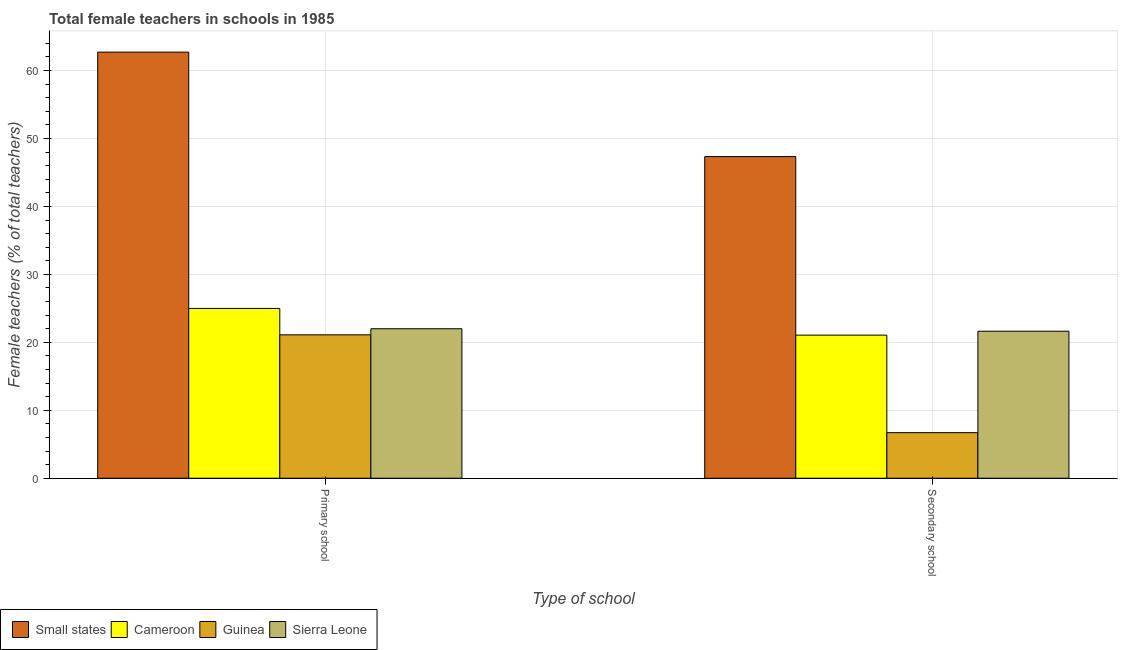How many different coloured bars are there?
Make the answer very short. 4. How many groups of bars are there?
Keep it short and to the point. 2. Are the number of bars per tick equal to the number of legend labels?
Your response must be concise. Yes. Are the number of bars on each tick of the X-axis equal?
Keep it short and to the point. Yes. What is the label of the 2nd group of bars from the left?
Offer a very short reply. Secondary school. What is the percentage of female teachers in secondary schools in Small states?
Offer a very short reply. 47.33. Across all countries, what is the maximum percentage of female teachers in primary schools?
Your response must be concise. 62.7. Across all countries, what is the minimum percentage of female teachers in secondary schools?
Your answer should be very brief. 6.71. In which country was the percentage of female teachers in secondary schools maximum?
Your response must be concise. Small states. In which country was the percentage of female teachers in secondary schools minimum?
Offer a very short reply. Guinea. What is the total percentage of female teachers in secondary schools in the graph?
Keep it short and to the point. 96.74. What is the difference between the percentage of female teachers in secondary schools in Cameroon and that in Guinea?
Keep it short and to the point. 14.35. What is the difference between the percentage of female teachers in primary schools in Cameroon and the percentage of female teachers in secondary schools in Guinea?
Your answer should be very brief. 18.28. What is the average percentage of female teachers in primary schools per country?
Offer a terse response. 32.7. What is the difference between the percentage of female teachers in secondary schools and percentage of female teachers in primary schools in Small states?
Give a very brief answer. -15.37. In how many countries, is the percentage of female teachers in secondary schools greater than 58 %?
Keep it short and to the point. 0. What is the ratio of the percentage of female teachers in secondary schools in Guinea to that in Small states?
Your answer should be compact. 0.14. Is the percentage of female teachers in primary schools in Small states less than that in Guinea?
Offer a very short reply. No. In how many countries, is the percentage of female teachers in secondary schools greater than the average percentage of female teachers in secondary schools taken over all countries?
Your answer should be very brief. 1. What does the 4th bar from the left in Secondary school represents?
Your response must be concise. Sierra Leone. What does the 3rd bar from the right in Secondary school represents?
Your answer should be very brief. Cameroon. Are all the bars in the graph horizontal?
Keep it short and to the point. No. Does the graph contain any zero values?
Your answer should be very brief. No. Does the graph contain grids?
Your response must be concise. Yes. How many legend labels are there?
Offer a very short reply. 4. What is the title of the graph?
Keep it short and to the point. Total female teachers in schools in 1985. Does "New Caledonia" appear as one of the legend labels in the graph?
Provide a short and direct response. No. What is the label or title of the X-axis?
Your response must be concise. Type of school. What is the label or title of the Y-axis?
Offer a terse response. Female teachers (% of total teachers). What is the Female teachers (% of total teachers) of Small states in Primary school?
Give a very brief answer. 62.7. What is the Female teachers (% of total teachers) of Cameroon in Primary school?
Your answer should be very brief. 24.99. What is the Female teachers (% of total teachers) in Guinea in Primary school?
Your answer should be very brief. 21.1. What is the Female teachers (% of total teachers) of Sierra Leone in Primary school?
Offer a terse response. 22. What is the Female teachers (% of total teachers) of Small states in Secondary school?
Your answer should be very brief. 47.33. What is the Female teachers (% of total teachers) of Cameroon in Secondary school?
Give a very brief answer. 21.06. What is the Female teachers (% of total teachers) of Guinea in Secondary school?
Provide a short and direct response. 6.71. What is the Female teachers (% of total teachers) of Sierra Leone in Secondary school?
Give a very brief answer. 21.64. Across all Type of school, what is the maximum Female teachers (% of total teachers) of Small states?
Offer a terse response. 62.7. Across all Type of school, what is the maximum Female teachers (% of total teachers) in Cameroon?
Provide a short and direct response. 24.99. Across all Type of school, what is the maximum Female teachers (% of total teachers) in Guinea?
Offer a very short reply. 21.1. Across all Type of school, what is the maximum Female teachers (% of total teachers) of Sierra Leone?
Provide a short and direct response. 22. Across all Type of school, what is the minimum Female teachers (% of total teachers) of Small states?
Ensure brevity in your answer.  47.33. Across all Type of school, what is the minimum Female teachers (% of total teachers) in Cameroon?
Your answer should be compact. 21.06. Across all Type of school, what is the minimum Female teachers (% of total teachers) in Guinea?
Make the answer very short. 6.71. Across all Type of school, what is the minimum Female teachers (% of total teachers) of Sierra Leone?
Give a very brief answer. 21.64. What is the total Female teachers (% of total teachers) in Small states in the graph?
Provide a short and direct response. 110.04. What is the total Female teachers (% of total teachers) of Cameroon in the graph?
Your answer should be compact. 46.04. What is the total Female teachers (% of total teachers) in Guinea in the graph?
Provide a short and direct response. 27.81. What is the total Female teachers (% of total teachers) in Sierra Leone in the graph?
Ensure brevity in your answer.  43.63. What is the difference between the Female teachers (% of total teachers) of Small states in Primary school and that in Secondary school?
Your response must be concise. 15.37. What is the difference between the Female teachers (% of total teachers) of Cameroon in Primary school and that in Secondary school?
Offer a very short reply. 3.93. What is the difference between the Female teachers (% of total teachers) in Guinea in Primary school and that in Secondary school?
Provide a short and direct response. 14.39. What is the difference between the Female teachers (% of total teachers) in Sierra Leone in Primary school and that in Secondary school?
Ensure brevity in your answer.  0.36. What is the difference between the Female teachers (% of total teachers) in Small states in Primary school and the Female teachers (% of total teachers) in Cameroon in Secondary school?
Offer a terse response. 41.65. What is the difference between the Female teachers (% of total teachers) in Small states in Primary school and the Female teachers (% of total teachers) in Guinea in Secondary school?
Offer a terse response. 56. What is the difference between the Female teachers (% of total teachers) of Small states in Primary school and the Female teachers (% of total teachers) of Sierra Leone in Secondary school?
Give a very brief answer. 41.07. What is the difference between the Female teachers (% of total teachers) in Cameroon in Primary school and the Female teachers (% of total teachers) in Guinea in Secondary school?
Ensure brevity in your answer.  18.28. What is the difference between the Female teachers (% of total teachers) of Cameroon in Primary school and the Female teachers (% of total teachers) of Sierra Leone in Secondary school?
Provide a succinct answer. 3.35. What is the difference between the Female teachers (% of total teachers) of Guinea in Primary school and the Female teachers (% of total teachers) of Sierra Leone in Secondary school?
Offer a terse response. -0.53. What is the average Female teachers (% of total teachers) of Small states per Type of school?
Your answer should be compact. 55.02. What is the average Female teachers (% of total teachers) in Cameroon per Type of school?
Make the answer very short. 23.02. What is the average Female teachers (% of total teachers) of Guinea per Type of school?
Offer a terse response. 13.91. What is the average Female teachers (% of total teachers) in Sierra Leone per Type of school?
Make the answer very short. 21.82. What is the difference between the Female teachers (% of total teachers) of Small states and Female teachers (% of total teachers) of Cameroon in Primary school?
Provide a succinct answer. 37.72. What is the difference between the Female teachers (% of total teachers) in Small states and Female teachers (% of total teachers) in Guinea in Primary school?
Ensure brevity in your answer.  41.6. What is the difference between the Female teachers (% of total teachers) in Small states and Female teachers (% of total teachers) in Sierra Leone in Primary school?
Make the answer very short. 40.71. What is the difference between the Female teachers (% of total teachers) in Cameroon and Female teachers (% of total teachers) in Guinea in Primary school?
Offer a very short reply. 3.88. What is the difference between the Female teachers (% of total teachers) of Cameroon and Female teachers (% of total teachers) of Sierra Leone in Primary school?
Ensure brevity in your answer.  2.99. What is the difference between the Female teachers (% of total teachers) in Guinea and Female teachers (% of total teachers) in Sierra Leone in Primary school?
Provide a short and direct response. -0.9. What is the difference between the Female teachers (% of total teachers) in Small states and Female teachers (% of total teachers) in Cameroon in Secondary school?
Your answer should be compact. 26.27. What is the difference between the Female teachers (% of total teachers) in Small states and Female teachers (% of total teachers) in Guinea in Secondary school?
Offer a terse response. 40.63. What is the difference between the Female teachers (% of total teachers) of Small states and Female teachers (% of total teachers) of Sierra Leone in Secondary school?
Your answer should be very brief. 25.7. What is the difference between the Female teachers (% of total teachers) of Cameroon and Female teachers (% of total teachers) of Guinea in Secondary school?
Offer a very short reply. 14.35. What is the difference between the Female teachers (% of total teachers) in Cameroon and Female teachers (% of total teachers) in Sierra Leone in Secondary school?
Make the answer very short. -0.58. What is the difference between the Female teachers (% of total teachers) in Guinea and Female teachers (% of total teachers) in Sierra Leone in Secondary school?
Keep it short and to the point. -14.93. What is the ratio of the Female teachers (% of total teachers) in Small states in Primary school to that in Secondary school?
Give a very brief answer. 1.32. What is the ratio of the Female teachers (% of total teachers) in Cameroon in Primary school to that in Secondary school?
Make the answer very short. 1.19. What is the ratio of the Female teachers (% of total teachers) of Guinea in Primary school to that in Secondary school?
Offer a very short reply. 3.15. What is the ratio of the Female teachers (% of total teachers) in Sierra Leone in Primary school to that in Secondary school?
Make the answer very short. 1.02. What is the difference between the highest and the second highest Female teachers (% of total teachers) of Small states?
Make the answer very short. 15.37. What is the difference between the highest and the second highest Female teachers (% of total teachers) in Cameroon?
Your answer should be compact. 3.93. What is the difference between the highest and the second highest Female teachers (% of total teachers) of Guinea?
Offer a very short reply. 14.39. What is the difference between the highest and the second highest Female teachers (% of total teachers) in Sierra Leone?
Ensure brevity in your answer.  0.36. What is the difference between the highest and the lowest Female teachers (% of total teachers) of Small states?
Ensure brevity in your answer.  15.37. What is the difference between the highest and the lowest Female teachers (% of total teachers) of Cameroon?
Offer a terse response. 3.93. What is the difference between the highest and the lowest Female teachers (% of total teachers) in Guinea?
Offer a terse response. 14.39. What is the difference between the highest and the lowest Female teachers (% of total teachers) of Sierra Leone?
Provide a succinct answer. 0.36. 